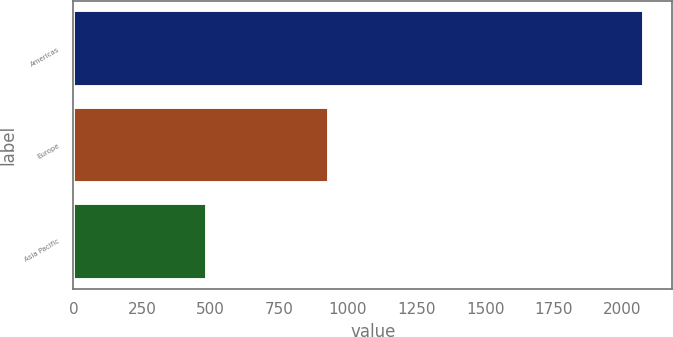Convert chart to OTSL. <chart><loc_0><loc_0><loc_500><loc_500><bar_chart><fcel>Americas<fcel>Europe<fcel>Asia Pacific<nl><fcel>2076.5<fcel>931.1<fcel>487.8<nl></chart> 